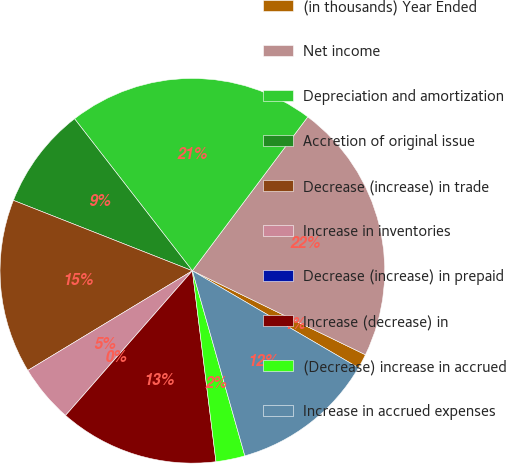<chart> <loc_0><loc_0><loc_500><loc_500><pie_chart><fcel>(in thousands) Year Ended<fcel>Net income<fcel>Depreciation and amortization<fcel>Accretion of original issue<fcel>Decrease (increase) in trade<fcel>Increase in inventories<fcel>Decrease (increase) in prepaid<fcel>Increase (decrease) in<fcel>(Decrease) increase in accrued<fcel>Increase in accrued expenses<nl><fcel>1.22%<fcel>21.95%<fcel>20.73%<fcel>8.54%<fcel>14.63%<fcel>4.88%<fcel>0.0%<fcel>13.41%<fcel>2.44%<fcel>12.19%<nl></chart> 